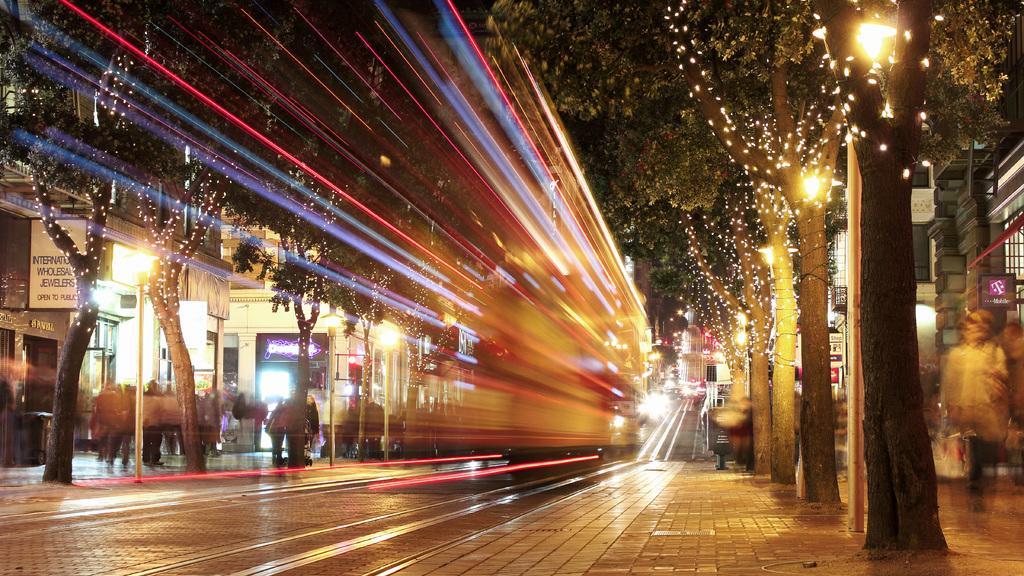Can you describe this image briefly? In this image, we can see lighting effects captured by camera. We can see trees are decorated with lights. In the background, we can see buildings, people, boards, street lights, walls, walkways and few objects. 